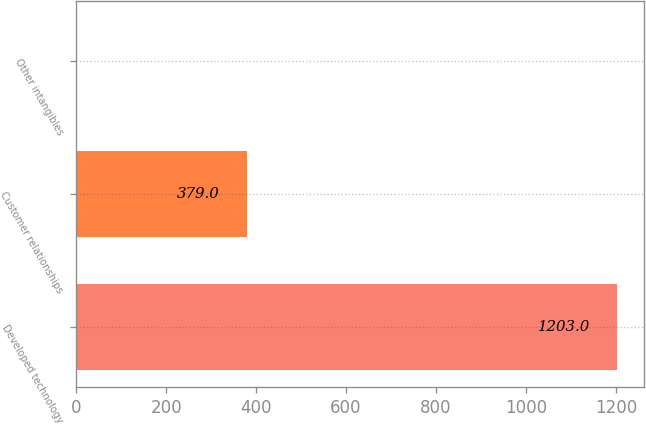<chart> <loc_0><loc_0><loc_500><loc_500><bar_chart><fcel>Developed technology<fcel>Customer relationships<fcel>Other intangibles<nl><fcel>1203<fcel>379<fcel>1<nl></chart> 